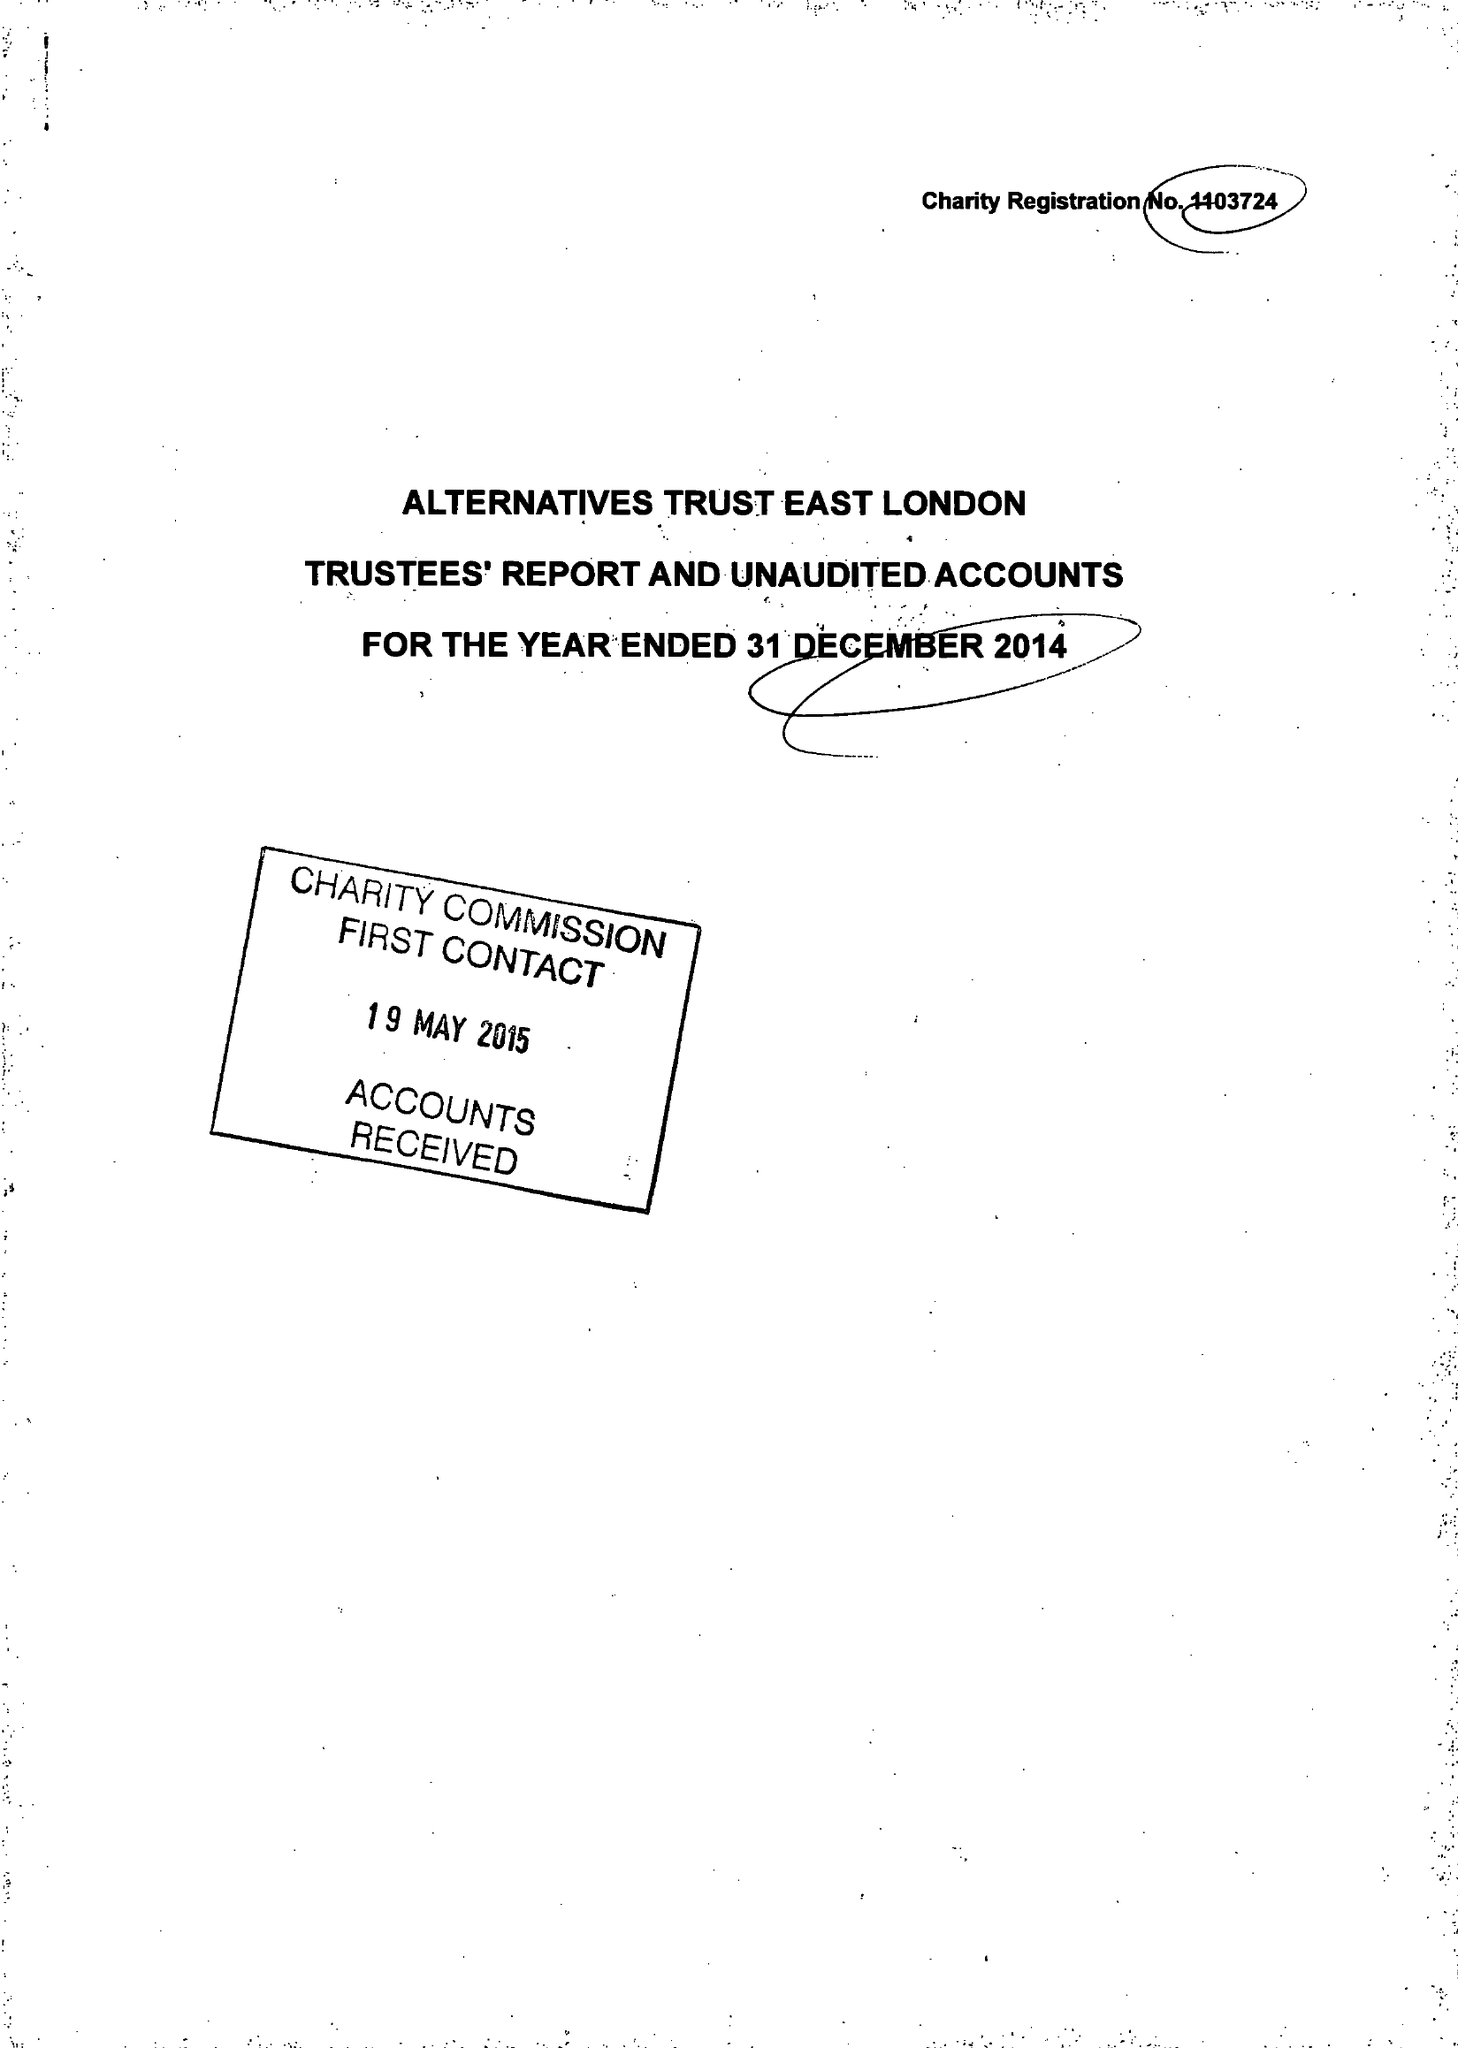What is the value for the charity_number?
Answer the question using a single word or phrase. 1103724 